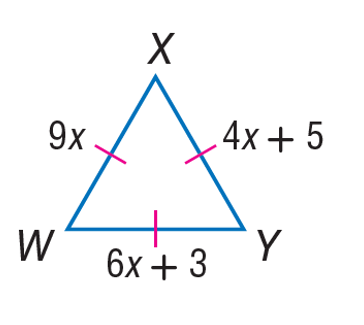Question: Find the length of W Y.
Choices:
A. 4
B. 5
C. 6
D. 9
Answer with the letter. Answer: D Question: Find the length of X W.
Choices:
A. 4
B. 5
C. 6
D. 9
Answer with the letter. Answer: D Question: Find the length of X Y.
Choices:
A. 4
B. 5
C. 6
D. 9
Answer with the letter. Answer: D 